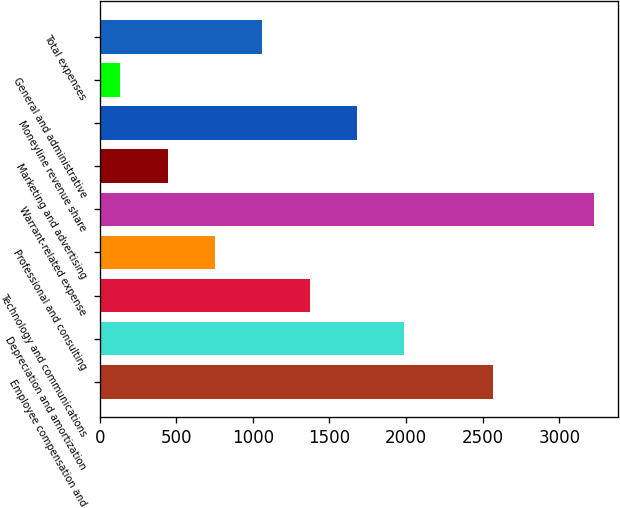Convert chart to OTSL. <chart><loc_0><loc_0><loc_500><loc_500><bar_chart><fcel>Employee compensation and<fcel>Depreciation and amortization<fcel>Technology and communications<fcel>Professional and consulting<fcel>Warrant-related expense<fcel>Marketing and advertising<fcel>Moneyline revenue share<fcel>General and administrative<fcel>Total expenses<nl><fcel>2570<fcel>1988.8<fcel>1371.2<fcel>753.6<fcel>3224<fcel>444.8<fcel>1680<fcel>136<fcel>1062.4<nl></chart> 